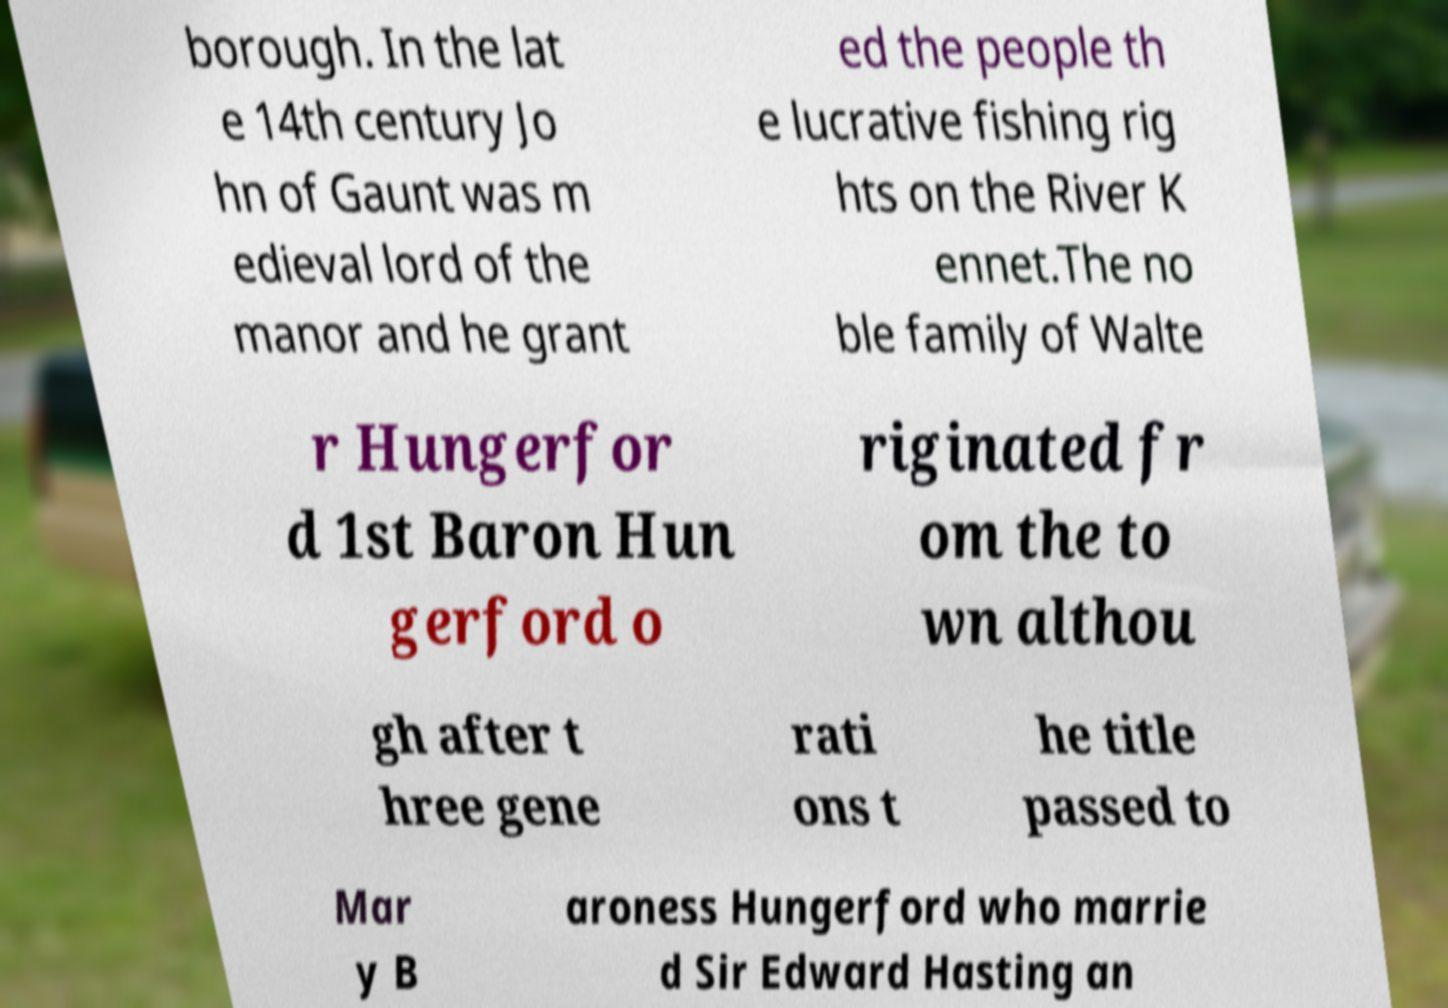Can you accurately transcribe the text from the provided image for me? borough. In the lat e 14th century Jo hn of Gaunt was m edieval lord of the manor and he grant ed the people th e lucrative fishing rig hts on the River K ennet.The no ble family of Walte r Hungerfor d 1st Baron Hun gerford o riginated fr om the to wn althou gh after t hree gene rati ons t he title passed to Mar y B aroness Hungerford who marrie d Sir Edward Hasting an 